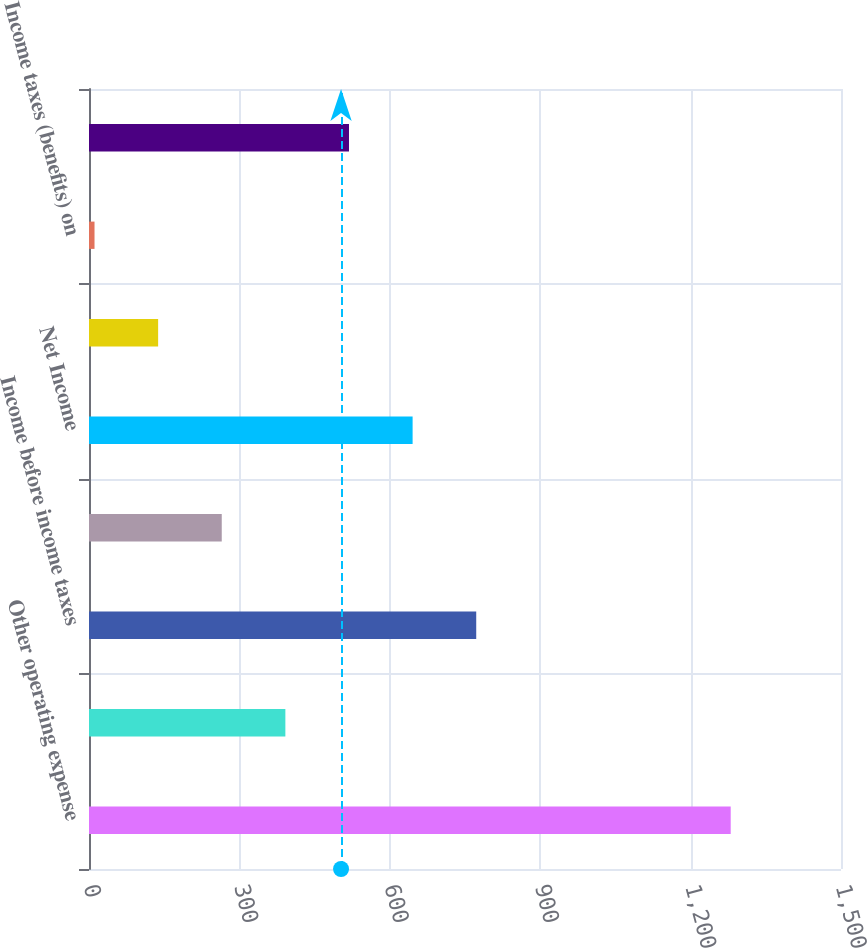<chart> <loc_0><loc_0><loc_500><loc_500><bar_chart><fcel>Other operating expense<fcel>Provision for depreciation<fcel>Income before income taxes<fcel>Income taxes<fcel>Net Income<fcel>Pension and other<fcel>Income taxes (benefits) on<fcel>Comprehensive income<nl><fcel>1280<fcel>391.7<fcel>772.4<fcel>264.8<fcel>645.5<fcel>137.9<fcel>11<fcel>518.6<nl></chart> 